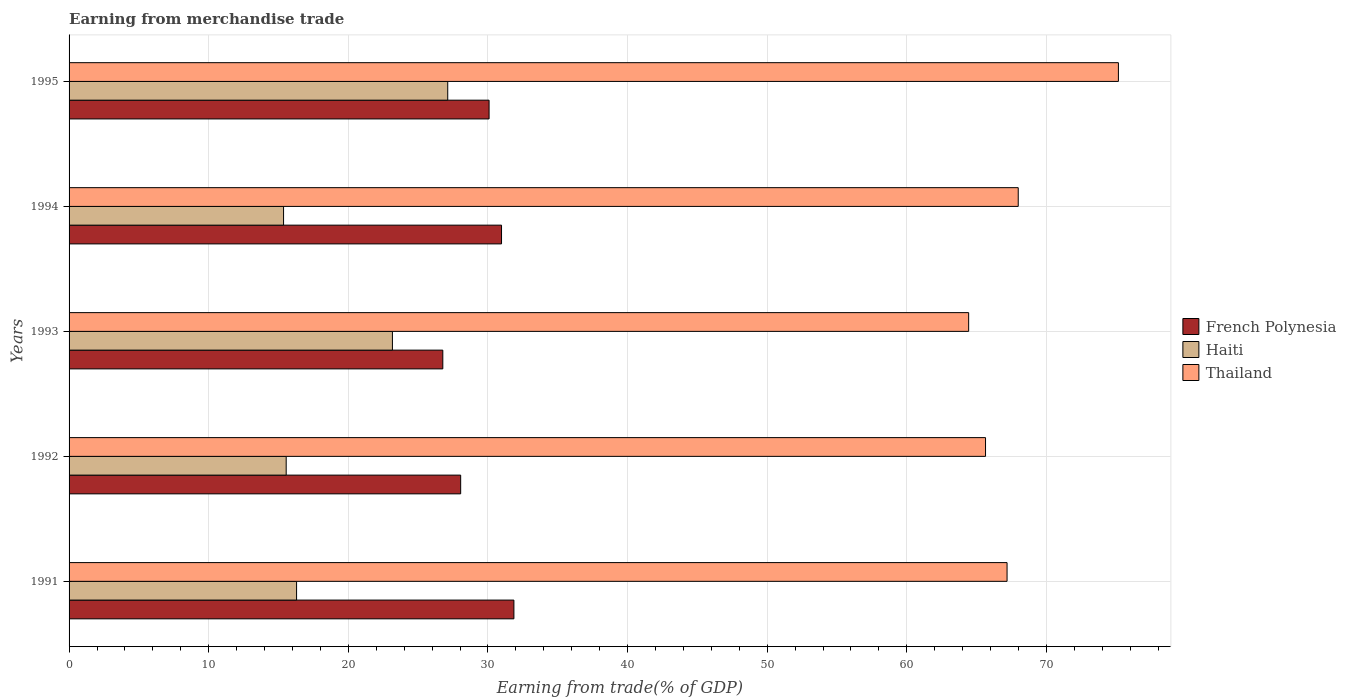How many different coloured bars are there?
Make the answer very short. 3. How many groups of bars are there?
Ensure brevity in your answer.  5. Are the number of bars on each tick of the Y-axis equal?
Keep it short and to the point. Yes. How many bars are there on the 2nd tick from the bottom?
Provide a short and direct response. 3. What is the label of the 4th group of bars from the top?
Make the answer very short. 1992. What is the earnings from trade in French Polynesia in 1993?
Your answer should be compact. 26.77. Across all years, what is the maximum earnings from trade in Thailand?
Provide a short and direct response. 75.16. Across all years, what is the minimum earnings from trade in Haiti?
Your response must be concise. 15.36. In which year was the earnings from trade in French Polynesia minimum?
Offer a very short reply. 1993. What is the total earnings from trade in French Polynesia in the graph?
Provide a succinct answer. 147.73. What is the difference between the earnings from trade in French Polynesia in 1992 and that in 1993?
Provide a short and direct response. 1.28. What is the difference between the earnings from trade in French Polynesia in 1991 and the earnings from trade in Thailand in 1995?
Ensure brevity in your answer.  -43.3. What is the average earnings from trade in Haiti per year?
Provide a succinct answer. 19.5. In the year 1995, what is the difference between the earnings from trade in French Polynesia and earnings from trade in Thailand?
Offer a terse response. -45.07. In how many years, is the earnings from trade in Haiti greater than 22 %?
Keep it short and to the point. 2. What is the ratio of the earnings from trade in French Polynesia in 1991 to that in 1993?
Give a very brief answer. 1.19. What is the difference between the highest and the second highest earnings from trade in Thailand?
Your answer should be very brief. 7.17. What is the difference between the highest and the lowest earnings from trade in French Polynesia?
Ensure brevity in your answer.  5.09. In how many years, is the earnings from trade in French Polynesia greater than the average earnings from trade in French Polynesia taken over all years?
Your answer should be very brief. 3. What does the 3rd bar from the top in 1991 represents?
Keep it short and to the point. French Polynesia. What does the 2nd bar from the bottom in 1992 represents?
Your answer should be compact. Haiti. Is it the case that in every year, the sum of the earnings from trade in Thailand and earnings from trade in Haiti is greater than the earnings from trade in French Polynesia?
Ensure brevity in your answer.  Yes. How many bars are there?
Provide a short and direct response. 15. What is the difference between two consecutive major ticks on the X-axis?
Make the answer very short. 10. How many legend labels are there?
Offer a very short reply. 3. What is the title of the graph?
Provide a short and direct response. Earning from merchandise trade. What is the label or title of the X-axis?
Your answer should be very brief. Earning from trade(% of GDP). What is the label or title of the Y-axis?
Your response must be concise. Years. What is the Earning from trade(% of GDP) in French Polynesia in 1991?
Your response must be concise. 31.86. What is the Earning from trade(% of GDP) in Haiti in 1991?
Offer a terse response. 16.29. What is the Earning from trade(% of GDP) of Thailand in 1991?
Keep it short and to the point. 67.18. What is the Earning from trade(% of GDP) in French Polynesia in 1992?
Ensure brevity in your answer.  28.05. What is the Earning from trade(% of GDP) in Haiti in 1992?
Give a very brief answer. 15.55. What is the Earning from trade(% of GDP) of Thailand in 1992?
Keep it short and to the point. 65.64. What is the Earning from trade(% of GDP) in French Polynesia in 1993?
Ensure brevity in your answer.  26.77. What is the Earning from trade(% of GDP) of Haiti in 1993?
Your answer should be compact. 23.16. What is the Earning from trade(% of GDP) of Thailand in 1993?
Make the answer very short. 64.43. What is the Earning from trade(% of GDP) of French Polynesia in 1994?
Keep it short and to the point. 30.97. What is the Earning from trade(% of GDP) in Haiti in 1994?
Your response must be concise. 15.36. What is the Earning from trade(% of GDP) of Thailand in 1994?
Your response must be concise. 67.98. What is the Earning from trade(% of GDP) in French Polynesia in 1995?
Give a very brief answer. 30.08. What is the Earning from trade(% of GDP) of Haiti in 1995?
Offer a terse response. 27.12. What is the Earning from trade(% of GDP) of Thailand in 1995?
Your answer should be very brief. 75.16. Across all years, what is the maximum Earning from trade(% of GDP) of French Polynesia?
Your response must be concise. 31.86. Across all years, what is the maximum Earning from trade(% of GDP) in Haiti?
Your answer should be compact. 27.12. Across all years, what is the maximum Earning from trade(% of GDP) of Thailand?
Offer a terse response. 75.16. Across all years, what is the minimum Earning from trade(% of GDP) of French Polynesia?
Keep it short and to the point. 26.77. Across all years, what is the minimum Earning from trade(% of GDP) in Haiti?
Keep it short and to the point. 15.36. Across all years, what is the minimum Earning from trade(% of GDP) in Thailand?
Ensure brevity in your answer.  64.43. What is the total Earning from trade(% of GDP) of French Polynesia in the graph?
Your answer should be compact. 147.73. What is the total Earning from trade(% of GDP) in Haiti in the graph?
Your answer should be compact. 97.49. What is the total Earning from trade(% of GDP) in Thailand in the graph?
Give a very brief answer. 340.4. What is the difference between the Earning from trade(% of GDP) of French Polynesia in 1991 and that in 1992?
Make the answer very short. 3.81. What is the difference between the Earning from trade(% of GDP) of Haiti in 1991 and that in 1992?
Give a very brief answer. 0.74. What is the difference between the Earning from trade(% of GDP) of Thailand in 1991 and that in 1992?
Provide a short and direct response. 1.54. What is the difference between the Earning from trade(% of GDP) in French Polynesia in 1991 and that in 1993?
Give a very brief answer. 5.09. What is the difference between the Earning from trade(% of GDP) of Haiti in 1991 and that in 1993?
Offer a terse response. -6.87. What is the difference between the Earning from trade(% of GDP) in Thailand in 1991 and that in 1993?
Ensure brevity in your answer.  2.75. What is the difference between the Earning from trade(% of GDP) in French Polynesia in 1991 and that in 1994?
Provide a short and direct response. 0.89. What is the difference between the Earning from trade(% of GDP) of Haiti in 1991 and that in 1994?
Your answer should be very brief. 0.93. What is the difference between the Earning from trade(% of GDP) in Thailand in 1991 and that in 1994?
Your response must be concise. -0.8. What is the difference between the Earning from trade(% of GDP) in French Polynesia in 1991 and that in 1995?
Your response must be concise. 1.78. What is the difference between the Earning from trade(% of GDP) in Haiti in 1991 and that in 1995?
Offer a very short reply. -10.83. What is the difference between the Earning from trade(% of GDP) in Thailand in 1991 and that in 1995?
Keep it short and to the point. -7.97. What is the difference between the Earning from trade(% of GDP) of French Polynesia in 1992 and that in 1993?
Provide a succinct answer. 1.28. What is the difference between the Earning from trade(% of GDP) of Haiti in 1992 and that in 1993?
Give a very brief answer. -7.61. What is the difference between the Earning from trade(% of GDP) in Thailand in 1992 and that in 1993?
Your response must be concise. 1.21. What is the difference between the Earning from trade(% of GDP) of French Polynesia in 1992 and that in 1994?
Ensure brevity in your answer.  -2.93. What is the difference between the Earning from trade(% of GDP) of Haiti in 1992 and that in 1994?
Make the answer very short. 0.19. What is the difference between the Earning from trade(% of GDP) in Thailand in 1992 and that in 1994?
Offer a very short reply. -2.34. What is the difference between the Earning from trade(% of GDP) in French Polynesia in 1992 and that in 1995?
Keep it short and to the point. -2.03. What is the difference between the Earning from trade(% of GDP) of Haiti in 1992 and that in 1995?
Make the answer very short. -11.57. What is the difference between the Earning from trade(% of GDP) in Thailand in 1992 and that in 1995?
Your answer should be very brief. -9.52. What is the difference between the Earning from trade(% of GDP) of French Polynesia in 1993 and that in 1994?
Provide a short and direct response. -4.21. What is the difference between the Earning from trade(% of GDP) of Haiti in 1993 and that in 1994?
Ensure brevity in your answer.  7.8. What is the difference between the Earning from trade(% of GDP) of Thailand in 1993 and that in 1994?
Give a very brief answer. -3.55. What is the difference between the Earning from trade(% of GDP) of French Polynesia in 1993 and that in 1995?
Offer a very short reply. -3.31. What is the difference between the Earning from trade(% of GDP) of Haiti in 1993 and that in 1995?
Provide a succinct answer. -3.96. What is the difference between the Earning from trade(% of GDP) of Thailand in 1993 and that in 1995?
Offer a very short reply. -10.73. What is the difference between the Earning from trade(% of GDP) in French Polynesia in 1994 and that in 1995?
Make the answer very short. 0.89. What is the difference between the Earning from trade(% of GDP) of Haiti in 1994 and that in 1995?
Your answer should be very brief. -11.76. What is the difference between the Earning from trade(% of GDP) in Thailand in 1994 and that in 1995?
Your answer should be very brief. -7.17. What is the difference between the Earning from trade(% of GDP) of French Polynesia in 1991 and the Earning from trade(% of GDP) of Haiti in 1992?
Give a very brief answer. 16.31. What is the difference between the Earning from trade(% of GDP) of French Polynesia in 1991 and the Earning from trade(% of GDP) of Thailand in 1992?
Offer a very short reply. -33.78. What is the difference between the Earning from trade(% of GDP) in Haiti in 1991 and the Earning from trade(% of GDP) in Thailand in 1992?
Keep it short and to the point. -49.35. What is the difference between the Earning from trade(% of GDP) in French Polynesia in 1991 and the Earning from trade(% of GDP) in Haiti in 1993?
Offer a very short reply. 8.7. What is the difference between the Earning from trade(% of GDP) in French Polynesia in 1991 and the Earning from trade(% of GDP) in Thailand in 1993?
Offer a terse response. -32.57. What is the difference between the Earning from trade(% of GDP) in Haiti in 1991 and the Earning from trade(% of GDP) in Thailand in 1993?
Provide a short and direct response. -48.14. What is the difference between the Earning from trade(% of GDP) of French Polynesia in 1991 and the Earning from trade(% of GDP) of Haiti in 1994?
Your answer should be compact. 16.5. What is the difference between the Earning from trade(% of GDP) of French Polynesia in 1991 and the Earning from trade(% of GDP) of Thailand in 1994?
Make the answer very short. -36.12. What is the difference between the Earning from trade(% of GDP) in Haiti in 1991 and the Earning from trade(% of GDP) in Thailand in 1994?
Give a very brief answer. -51.69. What is the difference between the Earning from trade(% of GDP) in French Polynesia in 1991 and the Earning from trade(% of GDP) in Haiti in 1995?
Offer a terse response. 4.74. What is the difference between the Earning from trade(% of GDP) in French Polynesia in 1991 and the Earning from trade(% of GDP) in Thailand in 1995?
Provide a short and direct response. -43.3. What is the difference between the Earning from trade(% of GDP) of Haiti in 1991 and the Earning from trade(% of GDP) of Thailand in 1995?
Give a very brief answer. -58.86. What is the difference between the Earning from trade(% of GDP) in French Polynesia in 1992 and the Earning from trade(% of GDP) in Haiti in 1993?
Make the answer very short. 4.89. What is the difference between the Earning from trade(% of GDP) of French Polynesia in 1992 and the Earning from trade(% of GDP) of Thailand in 1993?
Your answer should be very brief. -36.38. What is the difference between the Earning from trade(% of GDP) in Haiti in 1992 and the Earning from trade(% of GDP) in Thailand in 1993?
Provide a short and direct response. -48.88. What is the difference between the Earning from trade(% of GDP) of French Polynesia in 1992 and the Earning from trade(% of GDP) of Haiti in 1994?
Your answer should be very brief. 12.68. What is the difference between the Earning from trade(% of GDP) of French Polynesia in 1992 and the Earning from trade(% of GDP) of Thailand in 1994?
Your answer should be compact. -39.94. What is the difference between the Earning from trade(% of GDP) of Haiti in 1992 and the Earning from trade(% of GDP) of Thailand in 1994?
Your answer should be compact. -52.43. What is the difference between the Earning from trade(% of GDP) in French Polynesia in 1992 and the Earning from trade(% of GDP) in Haiti in 1995?
Make the answer very short. 0.93. What is the difference between the Earning from trade(% of GDP) in French Polynesia in 1992 and the Earning from trade(% of GDP) in Thailand in 1995?
Keep it short and to the point. -47.11. What is the difference between the Earning from trade(% of GDP) in Haiti in 1992 and the Earning from trade(% of GDP) in Thailand in 1995?
Your response must be concise. -59.61. What is the difference between the Earning from trade(% of GDP) in French Polynesia in 1993 and the Earning from trade(% of GDP) in Haiti in 1994?
Keep it short and to the point. 11.41. What is the difference between the Earning from trade(% of GDP) of French Polynesia in 1993 and the Earning from trade(% of GDP) of Thailand in 1994?
Offer a terse response. -41.21. What is the difference between the Earning from trade(% of GDP) of Haiti in 1993 and the Earning from trade(% of GDP) of Thailand in 1994?
Your answer should be very brief. -44.82. What is the difference between the Earning from trade(% of GDP) of French Polynesia in 1993 and the Earning from trade(% of GDP) of Haiti in 1995?
Make the answer very short. -0.35. What is the difference between the Earning from trade(% of GDP) of French Polynesia in 1993 and the Earning from trade(% of GDP) of Thailand in 1995?
Offer a terse response. -48.39. What is the difference between the Earning from trade(% of GDP) in Haiti in 1993 and the Earning from trade(% of GDP) in Thailand in 1995?
Provide a short and direct response. -52. What is the difference between the Earning from trade(% of GDP) of French Polynesia in 1994 and the Earning from trade(% of GDP) of Haiti in 1995?
Give a very brief answer. 3.85. What is the difference between the Earning from trade(% of GDP) of French Polynesia in 1994 and the Earning from trade(% of GDP) of Thailand in 1995?
Your response must be concise. -44.18. What is the difference between the Earning from trade(% of GDP) of Haiti in 1994 and the Earning from trade(% of GDP) of Thailand in 1995?
Keep it short and to the point. -59.79. What is the average Earning from trade(% of GDP) in French Polynesia per year?
Offer a terse response. 29.55. What is the average Earning from trade(% of GDP) of Haiti per year?
Your answer should be compact. 19.5. What is the average Earning from trade(% of GDP) in Thailand per year?
Ensure brevity in your answer.  68.08. In the year 1991, what is the difference between the Earning from trade(% of GDP) in French Polynesia and Earning from trade(% of GDP) in Haiti?
Your answer should be very brief. 15.57. In the year 1991, what is the difference between the Earning from trade(% of GDP) in French Polynesia and Earning from trade(% of GDP) in Thailand?
Ensure brevity in your answer.  -35.32. In the year 1991, what is the difference between the Earning from trade(% of GDP) in Haiti and Earning from trade(% of GDP) in Thailand?
Offer a very short reply. -50.89. In the year 1992, what is the difference between the Earning from trade(% of GDP) in French Polynesia and Earning from trade(% of GDP) in Haiti?
Keep it short and to the point. 12.5. In the year 1992, what is the difference between the Earning from trade(% of GDP) of French Polynesia and Earning from trade(% of GDP) of Thailand?
Offer a terse response. -37.59. In the year 1992, what is the difference between the Earning from trade(% of GDP) of Haiti and Earning from trade(% of GDP) of Thailand?
Offer a very short reply. -50.09. In the year 1993, what is the difference between the Earning from trade(% of GDP) of French Polynesia and Earning from trade(% of GDP) of Haiti?
Your response must be concise. 3.61. In the year 1993, what is the difference between the Earning from trade(% of GDP) in French Polynesia and Earning from trade(% of GDP) in Thailand?
Give a very brief answer. -37.66. In the year 1993, what is the difference between the Earning from trade(% of GDP) in Haiti and Earning from trade(% of GDP) in Thailand?
Your answer should be very brief. -41.27. In the year 1994, what is the difference between the Earning from trade(% of GDP) of French Polynesia and Earning from trade(% of GDP) of Haiti?
Ensure brevity in your answer.  15.61. In the year 1994, what is the difference between the Earning from trade(% of GDP) of French Polynesia and Earning from trade(% of GDP) of Thailand?
Ensure brevity in your answer.  -37.01. In the year 1994, what is the difference between the Earning from trade(% of GDP) of Haiti and Earning from trade(% of GDP) of Thailand?
Keep it short and to the point. -52.62. In the year 1995, what is the difference between the Earning from trade(% of GDP) in French Polynesia and Earning from trade(% of GDP) in Haiti?
Provide a short and direct response. 2.96. In the year 1995, what is the difference between the Earning from trade(% of GDP) of French Polynesia and Earning from trade(% of GDP) of Thailand?
Your answer should be compact. -45.07. In the year 1995, what is the difference between the Earning from trade(% of GDP) of Haiti and Earning from trade(% of GDP) of Thailand?
Make the answer very short. -48.04. What is the ratio of the Earning from trade(% of GDP) in French Polynesia in 1991 to that in 1992?
Offer a terse response. 1.14. What is the ratio of the Earning from trade(% of GDP) of Haiti in 1991 to that in 1992?
Your answer should be very brief. 1.05. What is the ratio of the Earning from trade(% of GDP) in Thailand in 1991 to that in 1992?
Keep it short and to the point. 1.02. What is the ratio of the Earning from trade(% of GDP) in French Polynesia in 1991 to that in 1993?
Offer a very short reply. 1.19. What is the ratio of the Earning from trade(% of GDP) in Haiti in 1991 to that in 1993?
Your response must be concise. 0.7. What is the ratio of the Earning from trade(% of GDP) in Thailand in 1991 to that in 1993?
Give a very brief answer. 1.04. What is the ratio of the Earning from trade(% of GDP) of French Polynesia in 1991 to that in 1994?
Provide a succinct answer. 1.03. What is the ratio of the Earning from trade(% of GDP) in Haiti in 1991 to that in 1994?
Make the answer very short. 1.06. What is the ratio of the Earning from trade(% of GDP) of Thailand in 1991 to that in 1994?
Offer a terse response. 0.99. What is the ratio of the Earning from trade(% of GDP) in French Polynesia in 1991 to that in 1995?
Keep it short and to the point. 1.06. What is the ratio of the Earning from trade(% of GDP) in Haiti in 1991 to that in 1995?
Provide a short and direct response. 0.6. What is the ratio of the Earning from trade(% of GDP) in Thailand in 1991 to that in 1995?
Provide a short and direct response. 0.89. What is the ratio of the Earning from trade(% of GDP) in French Polynesia in 1992 to that in 1993?
Give a very brief answer. 1.05. What is the ratio of the Earning from trade(% of GDP) in Haiti in 1992 to that in 1993?
Keep it short and to the point. 0.67. What is the ratio of the Earning from trade(% of GDP) in Thailand in 1992 to that in 1993?
Offer a very short reply. 1.02. What is the ratio of the Earning from trade(% of GDP) in French Polynesia in 1992 to that in 1994?
Make the answer very short. 0.91. What is the ratio of the Earning from trade(% of GDP) in Haiti in 1992 to that in 1994?
Provide a short and direct response. 1.01. What is the ratio of the Earning from trade(% of GDP) in Thailand in 1992 to that in 1994?
Make the answer very short. 0.97. What is the ratio of the Earning from trade(% of GDP) of French Polynesia in 1992 to that in 1995?
Keep it short and to the point. 0.93. What is the ratio of the Earning from trade(% of GDP) of Haiti in 1992 to that in 1995?
Your answer should be compact. 0.57. What is the ratio of the Earning from trade(% of GDP) of Thailand in 1992 to that in 1995?
Your answer should be very brief. 0.87. What is the ratio of the Earning from trade(% of GDP) in French Polynesia in 1993 to that in 1994?
Your answer should be compact. 0.86. What is the ratio of the Earning from trade(% of GDP) of Haiti in 1993 to that in 1994?
Ensure brevity in your answer.  1.51. What is the ratio of the Earning from trade(% of GDP) of Thailand in 1993 to that in 1994?
Keep it short and to the point. 0.95. What is the ratio of the Earning from trade(% of GDP) of French Polynesia in 1993 to that in 1995?
Provide a short and direct response. 0.89. What is the ratio of the Earning from trade(% of GDP) in Haiti in 1993 to that in 1995?
Give a very brief answer. 0.85. What is the ratio of the Earning from trade(% of GDP) of Thailand in 1993 to that in 1995?
Give a very brief answer. 0.86. What is the ratio of the Earning from trade(% of GDP) of French Polynesia in 1994 to that in 1995?
Provide a short and direct response. 1.03. What is the ratio of the Earning from trade(% of GDP) of Haiti in 1994 to that in 1995?
Offer a very short reply. 0.57. What is the ratio of the Earning from trade(% of GDP) of Thailand in 1994 to that in 1995?
Give a very brief answer. 0.9. What is the difference between the highest and the second highest Earning from trade(% of GDP) of French Polynesia?
Offer a very short reply. 0.89. What is the difference between the highest and the second highest Earning from trade(% of GDP) in Haiti?
Make the answer very short. 3.96. What is the difference between the highest and the second highest Earning from trade(% of GDP) of Thailand?
Ensure brevity in your answer.  7.17. What is the difference between the highest and the lowest Earning from trade(% of GDP) in French Polynesia?
Your response must be concise. 5.09. What is the difference between the highest and the lowest Earning from trade(% of GDP) of Haiti?
Offer a very short reply. 11.76. What is the difference between the highest and the lowest Earning from trade(% of GDP) in Thailand?
Make the answer very short. 10.73. 